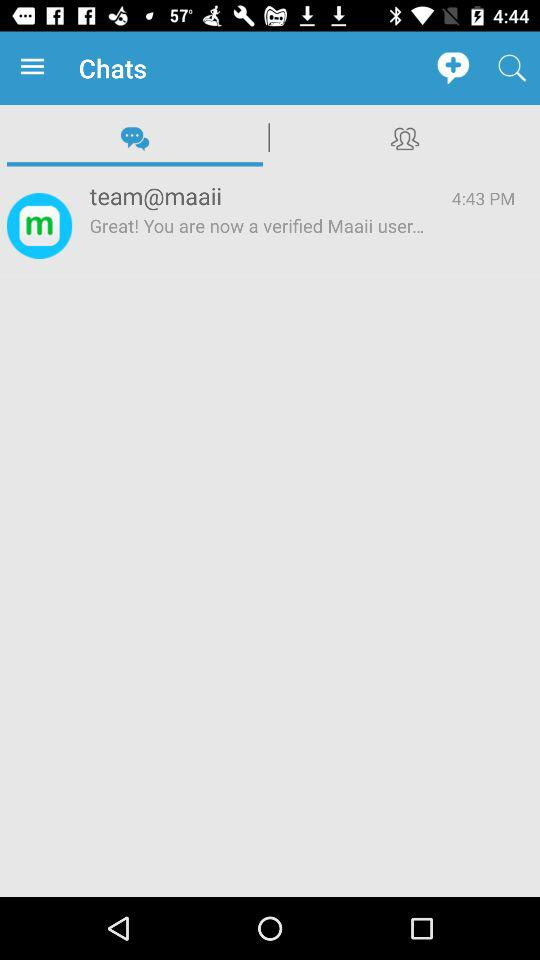What is the given time? The given time is 4:43 PM. 